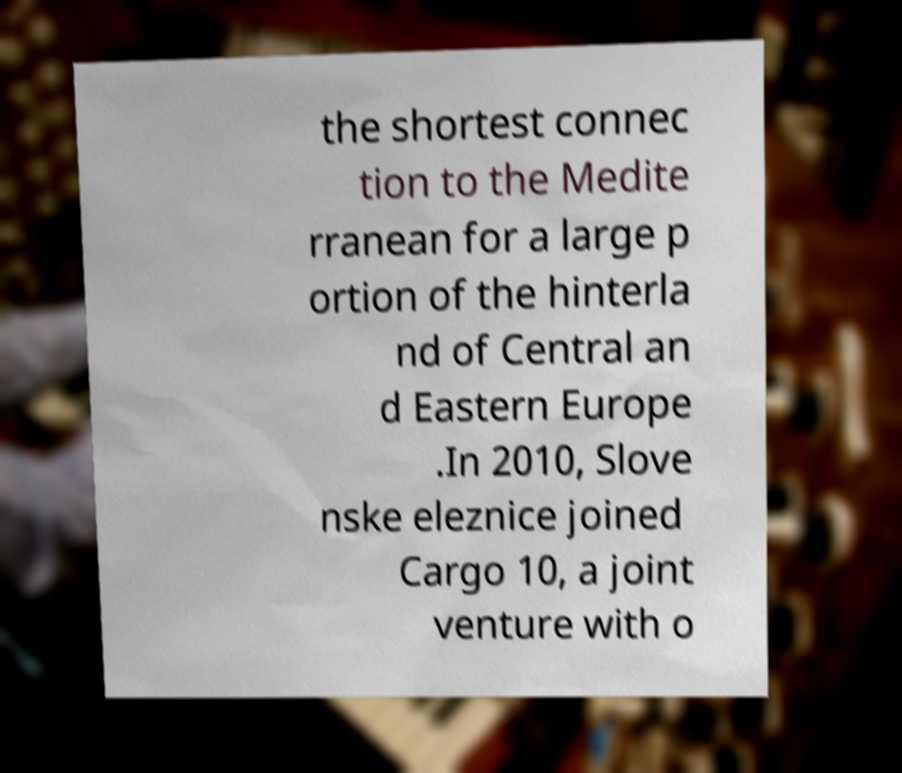Could you assist in decoding the text presented in this image and type it out clearly? the shortest connec tion to the Medite rranean for a large p ortion of the hinterla nd of Central an d Eastern Europe .In 2010, Slove nske eleznice joined Cargo 10, a joint venture with o 